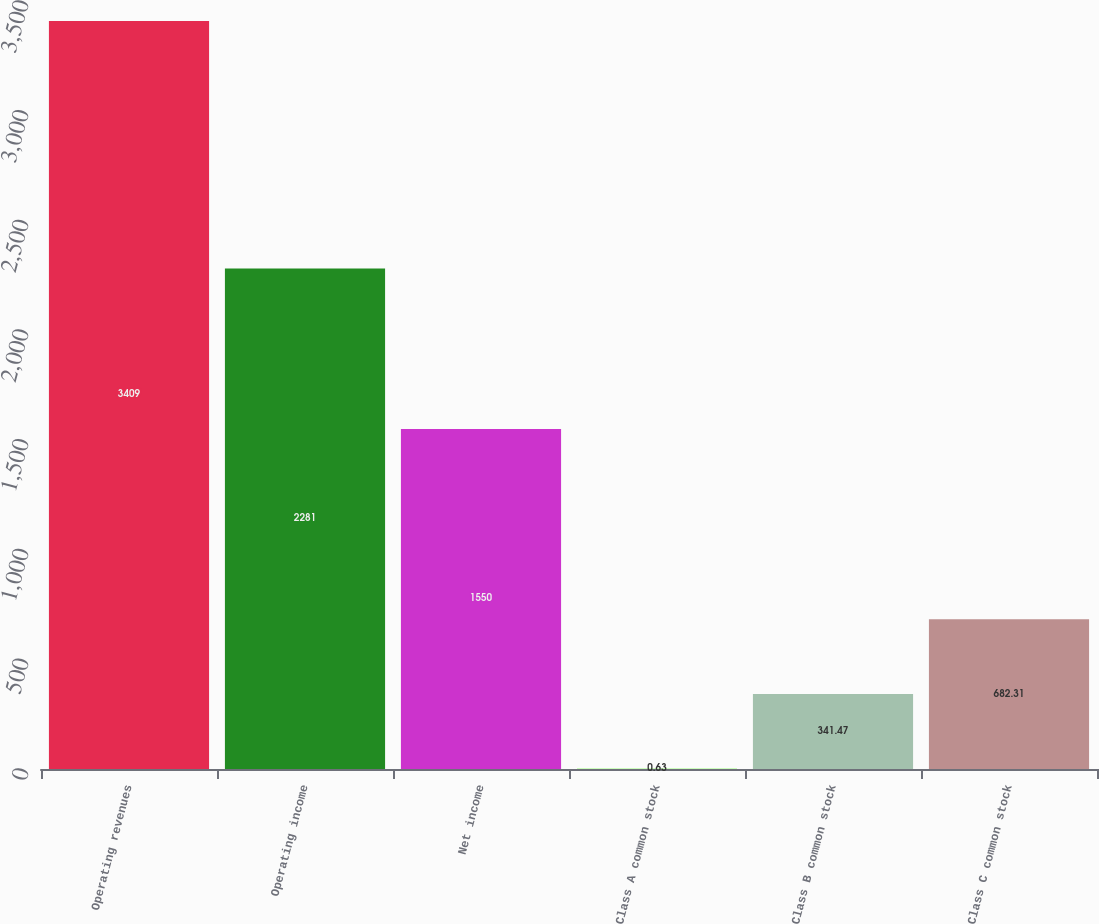<chart> <loc_0><loc_0><loc_500><loc_500><bar_chart><fcel>Operating revenues<fcel>Operating income<fcel>Net income<fcel>Class A common stock<fcel>Class B common stock<fcel>Class C common stock<nl><fcel>3409<fcel>2281<fcel>1550<fcel>0.63<fcel>341.47<fcel>682.31<nl></chart> 